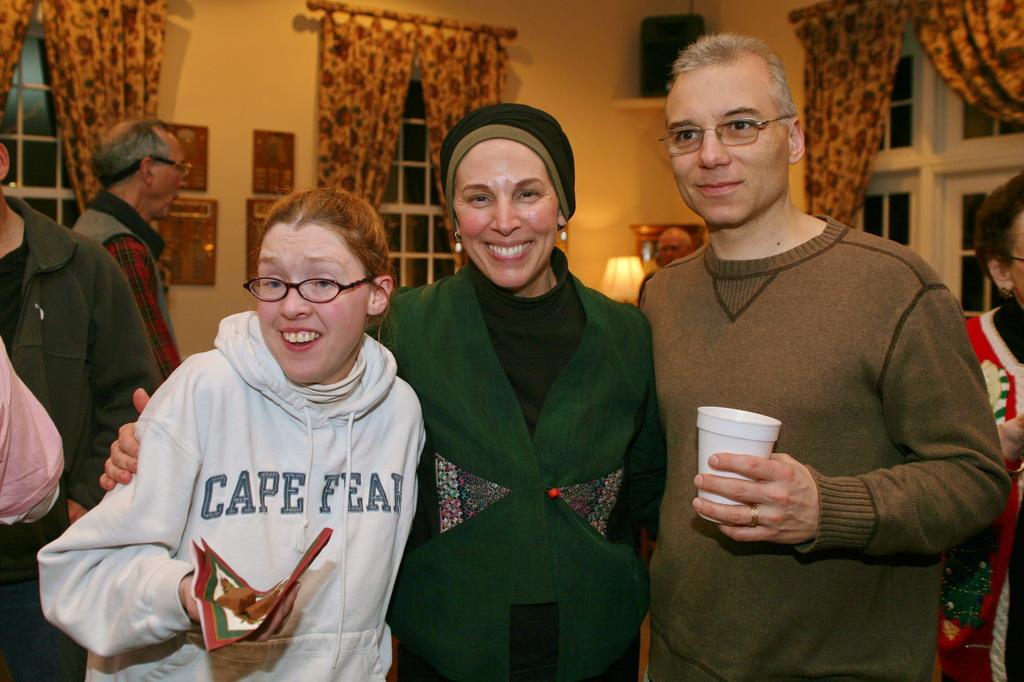How would you summarize this image in a sentence or two? In this picture there are people, among them these three people standing and smiling. In the background of the image we can see curtains, windows, object on the shelf, light and boards on the wall. 